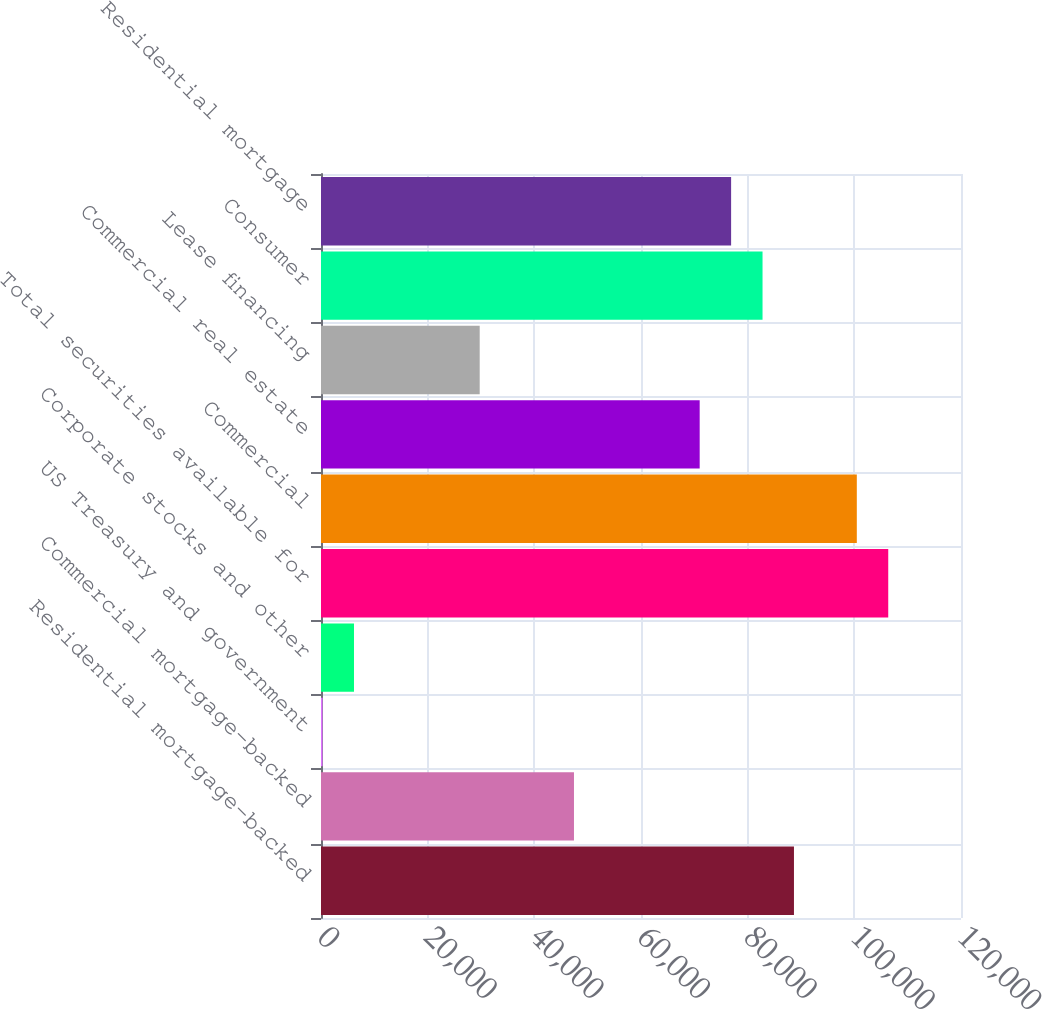Convert chart. <chart><loc_0><loc_0><loc_500><loc_500><bar_chart><fcel>Residential mortgage-backed<fcel>Commercial mortgage-backed<fcel>US Treasury and government<fcel>Corporate stocks and other<fcel>Total securities available for<fcel>Commercial<fcel>Commercial real estate<fcel>Lease financing<fcel>Consumer<fcel>Residential mortgage<nl><fcel>88680.5<fcel>47433<fcel>293<fcel>6185.5<fcel>106358<fcel>100466<fcel>71003<fcel>29755.5<fcel>82788<fcel>76895.5<nl></chart> 